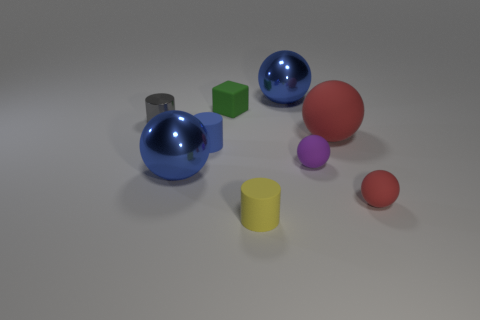What number of objects are red rubber spheres that are behind the small red matte ball or green matte cubes that are behind the tiny yellow thing?
Offer a terse response. 2. There is a small matte block; is it the same color as the large metal ball behind the big red matte sphere?
Keep it short and to the point. No. There is a tiny blue object that is made of the same material as the small yellow object; what is its shape?
Make the answer very short. Cylinder. How many small spheres are there?
Offer a very short reply. 2. What number of things are either matte spheres in front of the small purple matte thing or tiny gray shiny objects?
Provide a succinct answer. 2. Do the metal thing in front of the purple object and the metallic cylinder have the same color?
Provide a succinct answer. No. What number of other objects are the same color as the big matte ball?
Ensure brevity in your answer.  1. How many big things are either cylinders or red rubber balls?
Offer a terse response. 1. Is the number of large red objects greater than the number of small cyan matte cylinders?
Make the answer very short. Yes. Is the small green object made of the same material as the small yellow object?
Your answer should be very brief. Yes. 